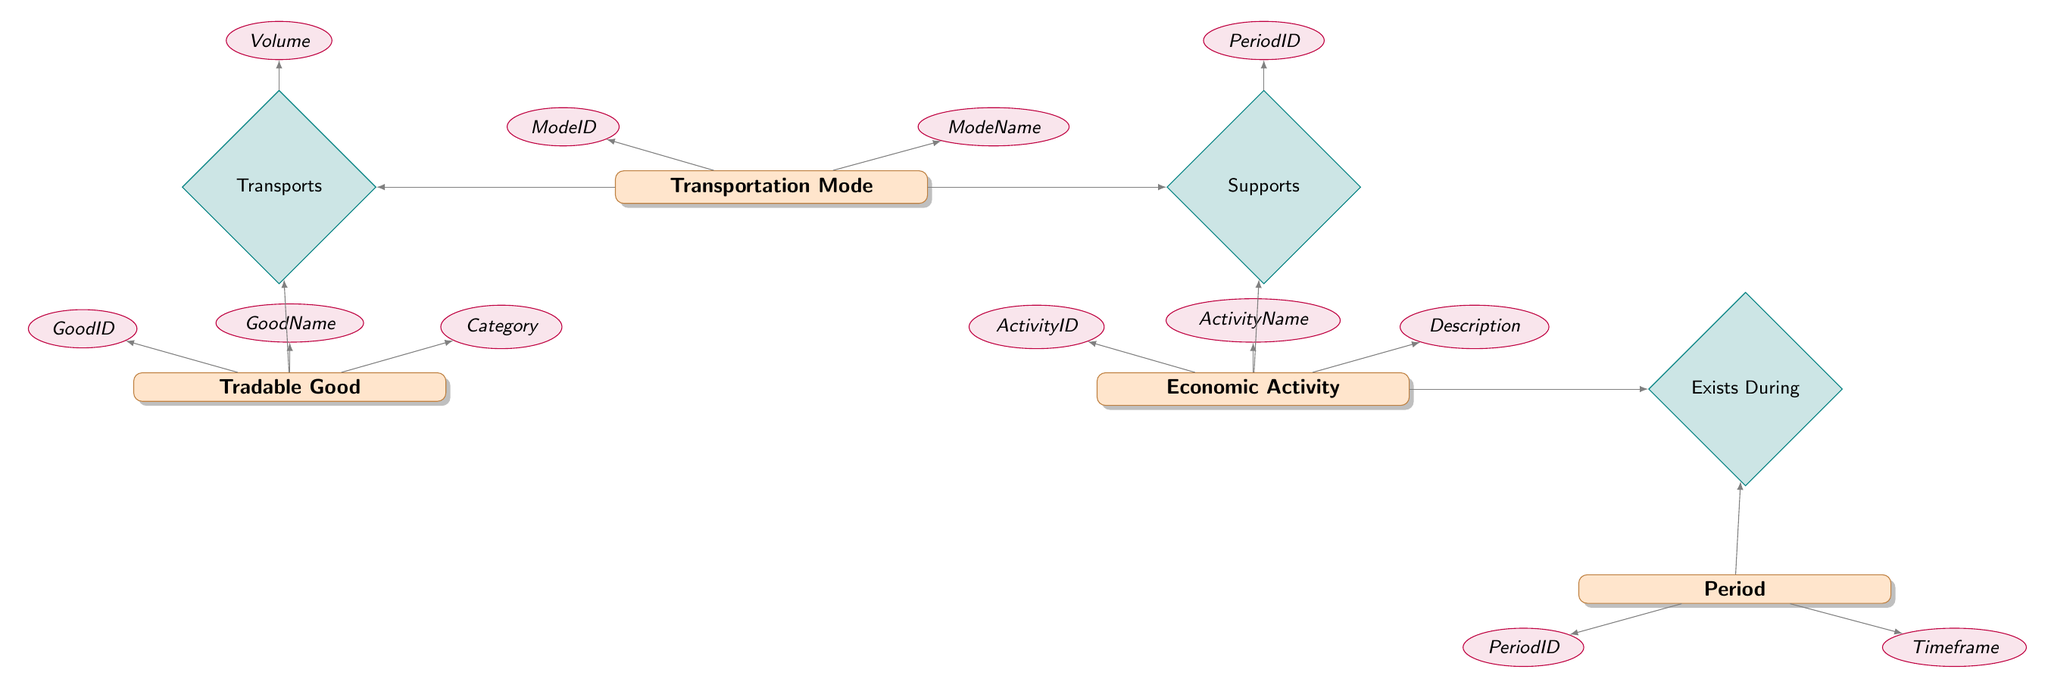What entities are present in the diagram? The diagram includes four entities: TransportationMode, EconomicActivity, TradableGood, and Period. These can be identified by looking at the rectangles in the diagram, each labeled with the name of an entity.
Answer: TransportationMode, EconomicActivity, TradableGood, Period How many attributes does the EconomicActivity entity have? The EconomicActivity entity has three attributes: ActivityID, ActivityName, and Description. This can be confirmed by counting the number of ellipses connected to the EconomicActivity entity in the diagram.
Answer: Three What relationship connects TransportationMode and EconomicActivity? The relationship connecting TransportationMode and EconomicActivity is named Supports. This is identified by the diamond shape labeled 'Supports' located between the TransportationMode and EconomicActivity entities.
Answer: Supports Which entity has the attribute ModeName? The attribute ModeName belongs to the TransportationMode entity. This is evident from the ellipse with the label ModeName which is linked directly to the TransportationMode rectangle in the diagram.
Answer: TransportationMode What is the purpose of the Transports relationship? The Transports relationship specifies how different Transportation Modes are responsible for transporting Tradable Goods. It indicates a function, linking the two entities through the volume of goods moved. This can be inferred by the labels and connections to both TransportationMode and TradableGood.
Answer: To indicate transporting goods Which entity is connected to the ExistsDuring relationship? The ExistsDuring relationship connects EconomicActivity and Period. This is clear from the labeling and the direct connection represented by the line extending from the EconomicActivity entity to the ExistsDuring diamond and then to the Period entity.
Answer: EconomicActivity and Period What is the volume associated with the Transports relationship used for? The volume associated with the Transports relationship is used to quantify the amount of Tradable Good transported by a specific Transportation Mode. This is indicated by the attribute labeled 'Volume' connected to the Transports relationship in the diagram.
Answer: To quantify transportation amount How many relationships are depicted in the diagram? There are three relationships depicted in the diagram: Supports, Transports, and Exists During. This can be determined by counting the number of diamond shapes present in the diagram.
Answer: Three What does the entity TradableGood represent? The entity TradableGood represents items that can be transported and sold, categorized into different types. This understanding comes from interpreting its name and associated connections within the context of the diagram.
Answer: Items for transportation and sale 